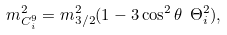<formula> <loc_0><loc_0><loc_500><loc_500>m _ { C _ { i } ^ { 9 } } ^ { 2 } = m _ { 3 / 2 } ^ { 2 } ( 1 - 3 \cos ^ { 2 } \theta \ \Theta ^ { 2 } _ { i } ) ,</formula> 